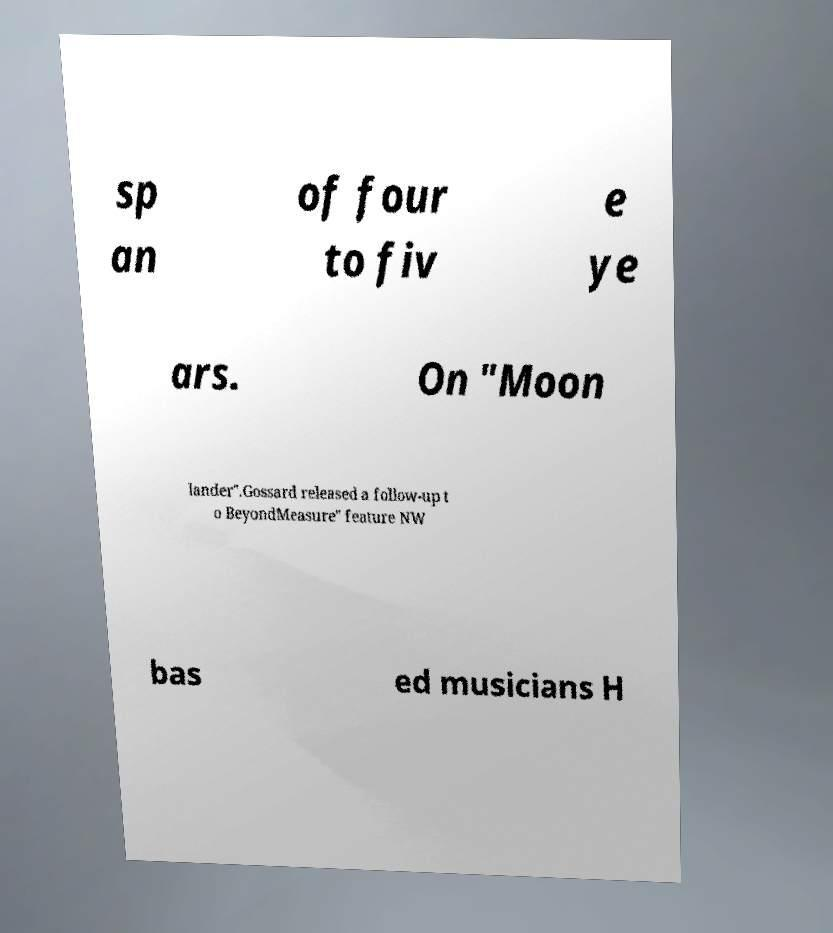Could you assist in decoding the text presented in this image and type it out clearly? sp an of four to fiv e ye ars. On "Moon lander".Gossard released a follow-up t o BeyondMeasure" feature NW bas ed musicians H 